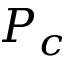<formula> <loc_0><loc_0><loc_500><loc_500>P _ { c }</formula> 